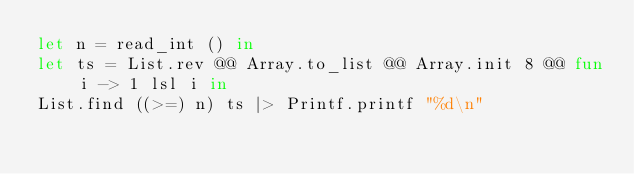Convert code to text. <code><loc_0><loc_0><loc_500><loc_500><_OCaml_>let n = read_int () in
let ts = List.rev @@ Array.to_list @@ Array.init 8 @@ fun i -> 1 lsl i in
List.find ((>=) n) ts |> Printf.printf "%d\n"</code> 